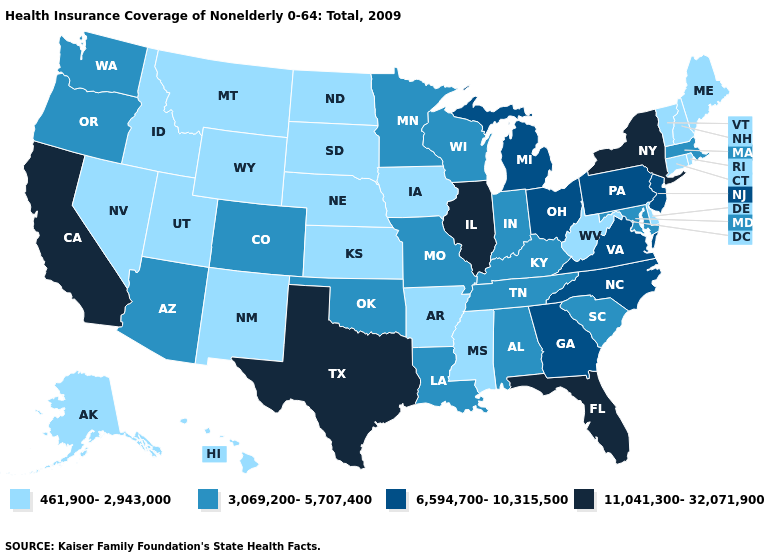Does the first symbol in the legend represent the smallest category?
Concise answer only. Yes. Does the first symbol in the legend represent the smallest category?
Quick response, please. Yes. Name the states that have a value in the range 6,594,700-10,315,500?
Write a very short answer. Georgia, Michigan, New Jersey, North Carolina, Ohio, Pennsylvania, Virginia. Name the states that have a value in the range 11,041,300-32,071,900?
Be succinct. California, Florida, Illinois, New York, Texas. What is the lowest value in states that border Vermont?
Short answer required. 461,900-2,943,000. What is the value of Ohio?
Concise answer only. 6,594,700-10,315,500. What is the value of Connecticut?
Quick response, please. 461,900-2,943,000. Which states have the highest value in the USA?
Write a very short answer. California, Florida, Illinois, New York, Texas. Among the states that border New Jersey , does Delaware have the highest value?
Answer briefly. No. What is the highest value in the USA?
Be succinct. 11,041,300-32,071,900. What is the value of Montana?
Short answer required. 461,900-2,943,000. Name the states that have a value in the range 461,900-2,943,000?
Give a very brief answer. Alaska, Arkansas, Connecticut, Delaware, Hawaii, Idaho, Iowa, Kansas, Maine, Mississippi, Montana, Nebraska, Nevada, New Hampshire, New Mexico, North Dakota, Rhode Island, South Dakota, Utah, Vermont, West Virginia, Wyoming. What is the highest value in the USA?
Write a very short answer. 11,041,300-32,071,900. What is the value of Maine?
Short answer required. 461,900-2,943,000. Name the states that have a value in the range 11,041,300-32,071,900?
Keep it brief. California, Florida, Illinois, New York, Texas. 